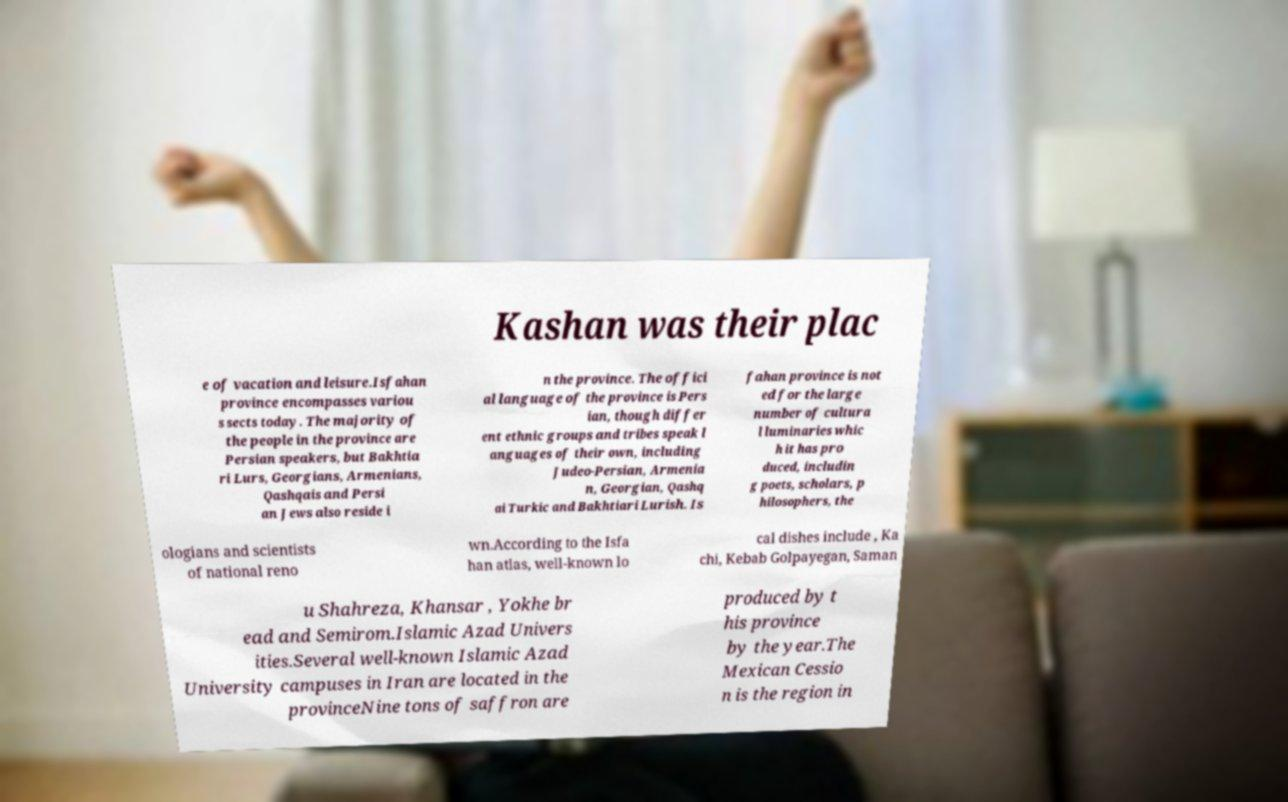Could you extract and type out the text from this image? Kashan was their plac e of vacation and leisure.Isfahan province encompasses variou s sects today. The majority of the people in the province are Persian speakers, but Bakhtia ri Lurs, Georgians, Armenians, Qashqais and Persi an Jews also reside i n the province. The offici al language of the province is Pers ian, though differ ent ethnic groups and tribes speak l anguages of their own, including Judeo-Persian, Armenia n, Georgian, Qashq ai Turkic and Bakhtiari Lurish. Is fahan province is not ed for the large number of cultura l luminaries whic h it has pro duced, includin g poets, scholars, p hilosophers, the ologians and scientists of national reno wn.According to the Isfa han atlas, well-known lo cal dishes include , Ka chi, Kebab Golpayegan, Saman u Shahreza, Khansar , Yokhe br ead and Semirom.Islamic Azad Univers ities.Several well-known Islamic Azad University campuses in Iran are located in the provinceNine tons of saffron are produced by t his province by the year.The Mexican Cessio n is the region in 